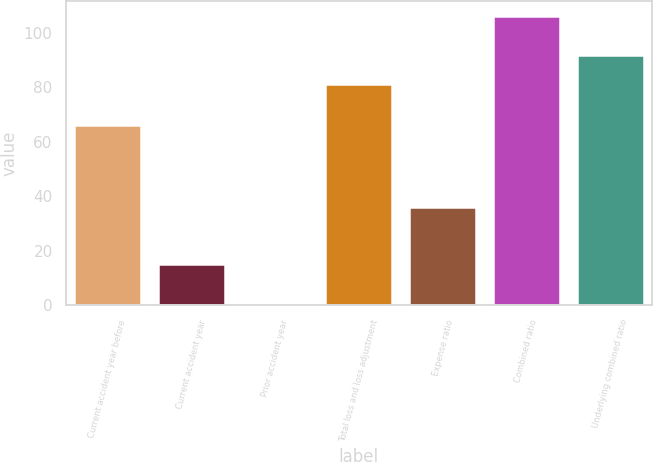Convert chart to OTSL. <chart><loc_0><loc_0><loc_500><loc_500><bar_chart><fcel>Current accident year before<fcel>Current accident year<fcel>Prior accident year<fcel>Total loss and loss adjustment<fcel>Expense ratio<fcel>Combined ratio<fcel>Underlying combined ratio<nl><fcel>66.2<fcel>15.2<fcel>0.9<fcel>81.3<fcel>36.28<fcel>106.3<fcel>91.84<nl></chart> 